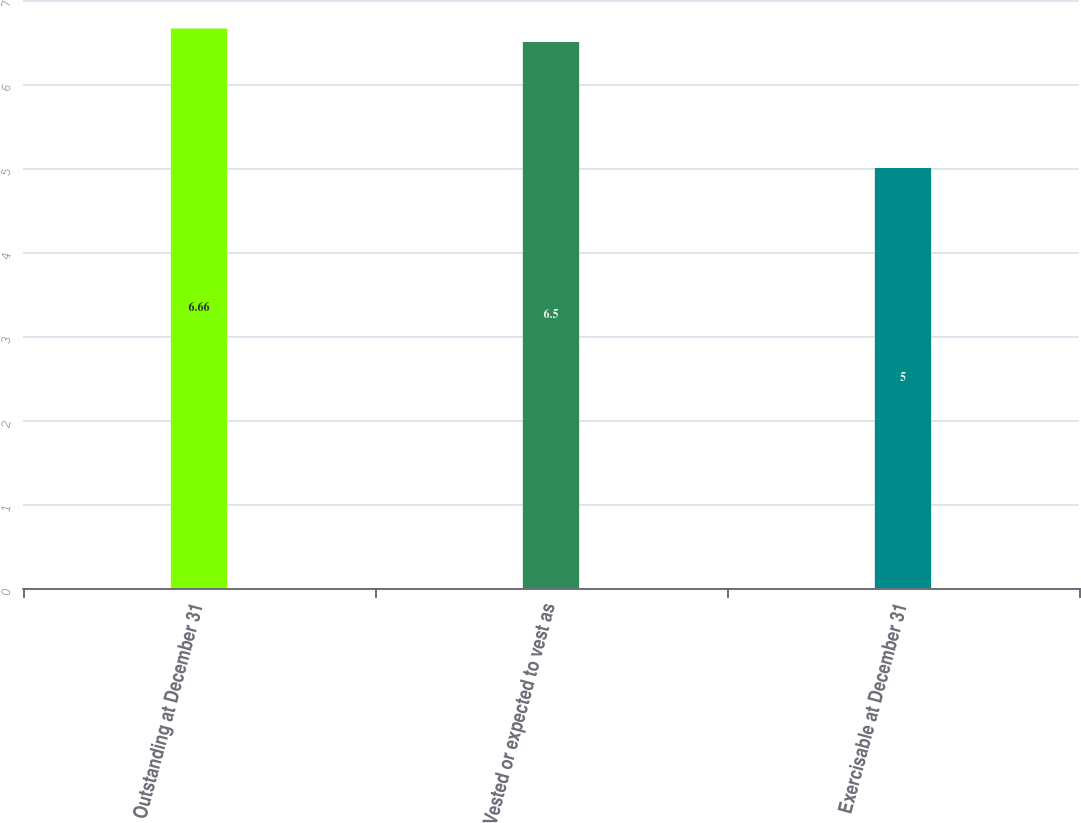Convert chart to OTSL. <chart><loc_0><loc_0><loc_500><loc_500><bar_chart><fcel>Outstanding at December 31<fcel>Vested or expected to vest as<fcel>Exercisable at December 31<nl><fcel>6.66<fcel>6.5<fcel>5<nl></chart> 